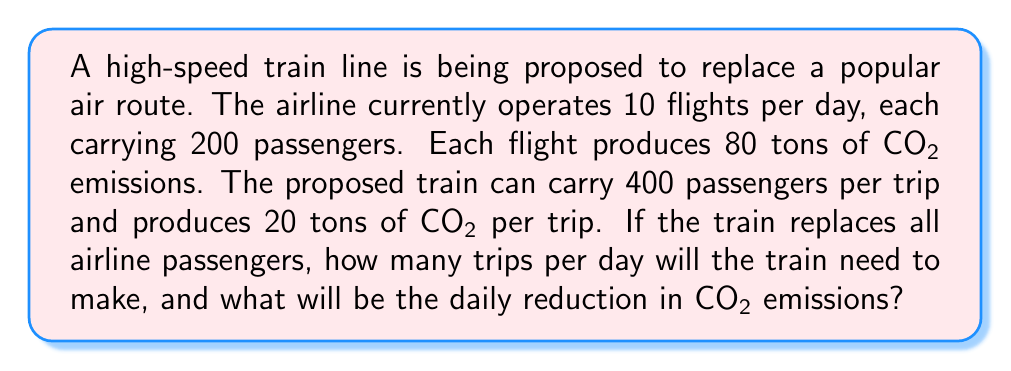Show me your answer to this math problem. 1. Calculate the total number of airline passengers per day:
   $10 \text{ flights} \times 200 \text{ passengers} = 2000 \text{ passengers}$

2. Calculate the number of train trips needed:
   $$\text{Train trips} = \frac{\text{Total passengers}}{\text{Train capacity}} = \frac{2000}{400} = 5 \text{ trips}$$

3. Calculate the daily CO₂ emissions from air travel:
   $10 \text{ flights} \times 80 \text{ tons CO₂} = 800 \text{ tons CO₂}$

4. Calculate the daily CO₂ emissions from train travel:
   $5 \text{ trips} \times 20 \text{ tons CO₂} = 100 \text{ tons CO₂}$

5. Calculate the daily reduction in CO₂ emissions:
   $$\text{CO₂ reduction} = \text{Air emissions} - \text{Train emissions}$$
   $$= 800 \text{ tons} - 100 \text{ tons} = 700 \text{ tons}$$
Answer: 5 train trips; 700 tons CO₂ reduction 